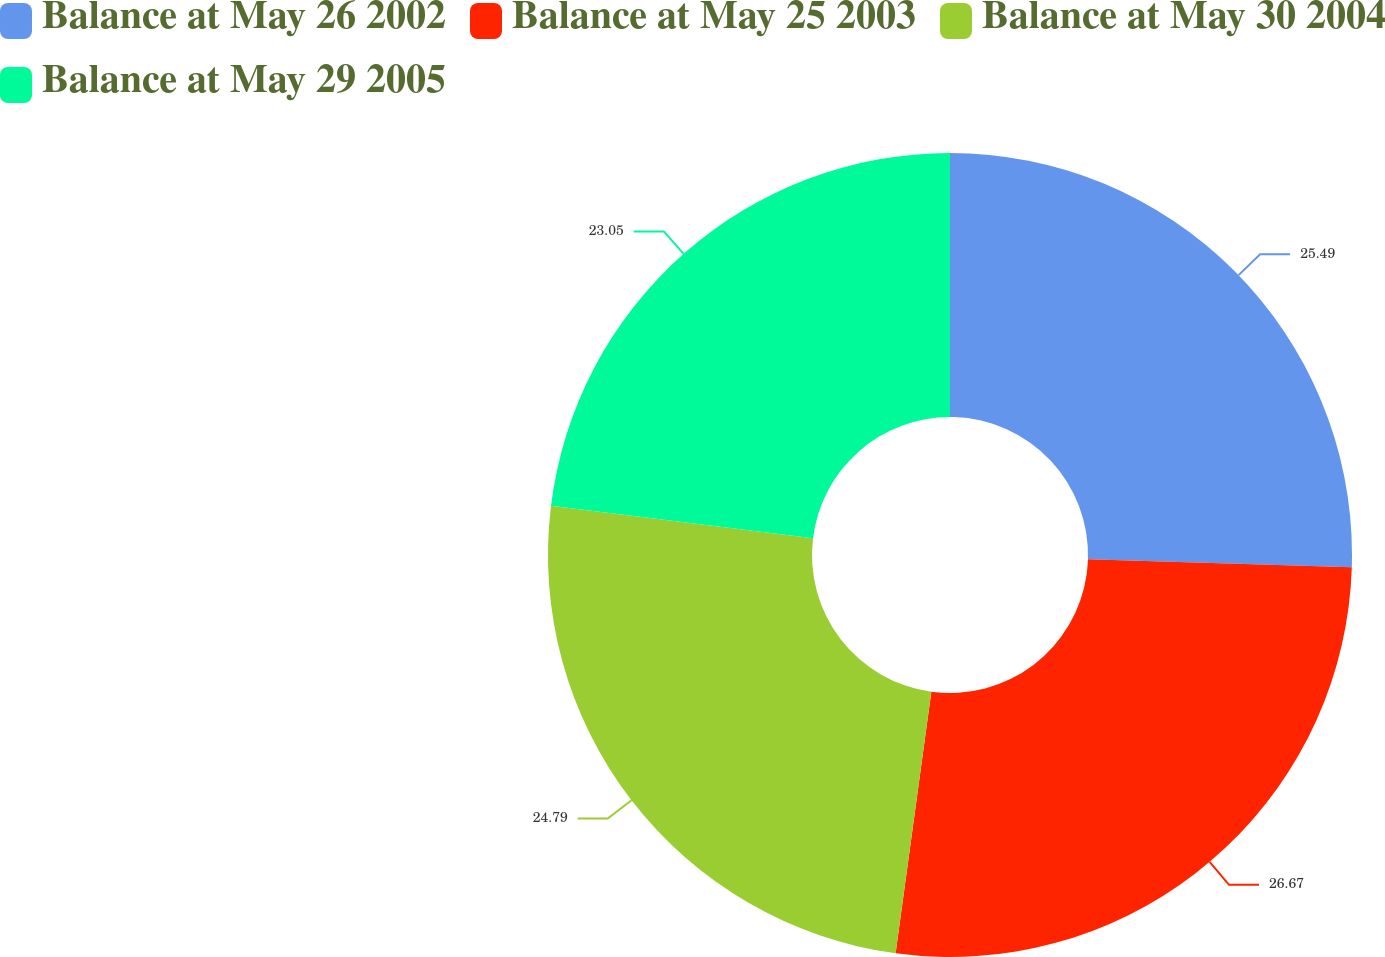Convert chart. <chart><loc_0><loc_0><loc_500><loc_500><pie_chart><fcel>Balance at May 26 2002<fcel>Balance at May 25 2003<fcel>Balance at May 30 2004<fcel>Balance at May 29 2005<nl><fcel>25.49%<fcel>26.67%<fcel>24.79%<fcel>23.05%<nl></chart> 